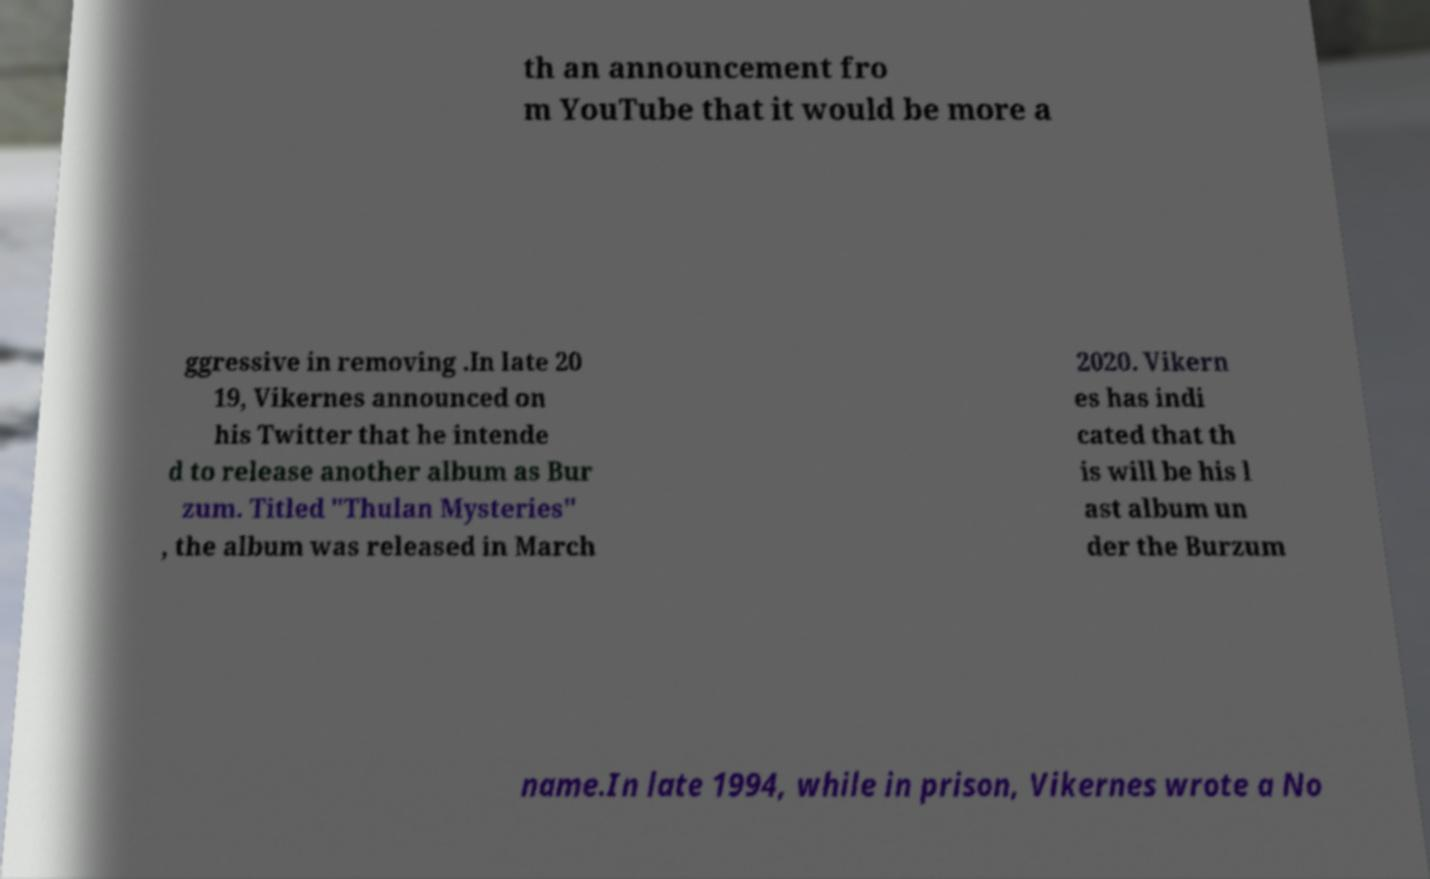Could you extract and type out the text from this image? th an announcement fro m YouTube that it would be more a ggressive in removing .In late 20 19, Vikernes announced on his Twitter that he intende d to release another album as Bur zum. Titled "Thulan Mysteries" , the album was released in March 2020. Vikern es has indi cated that th is will be his l ast album un der the Burzum name.In late 1994, while in prison, Vikernes wrote a No 